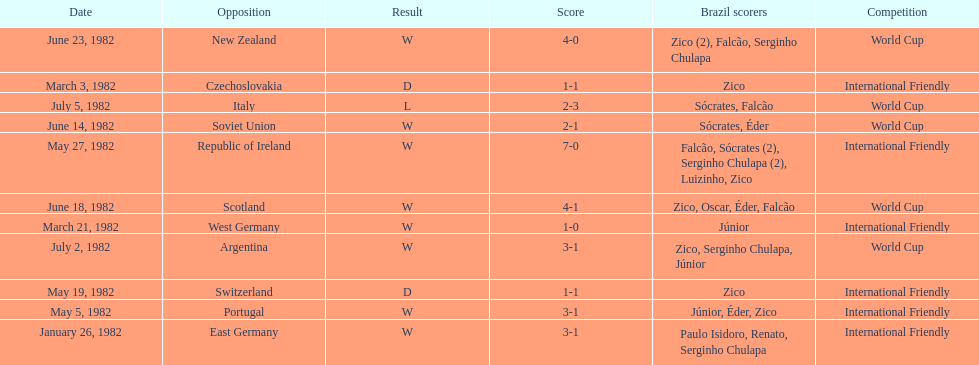How many goals did brazil score against the soviet union? 2-1. How many goals did brazil score against portugal? 3-1. Did brazil score more goals against portugal or the soviet union? Portugal. 